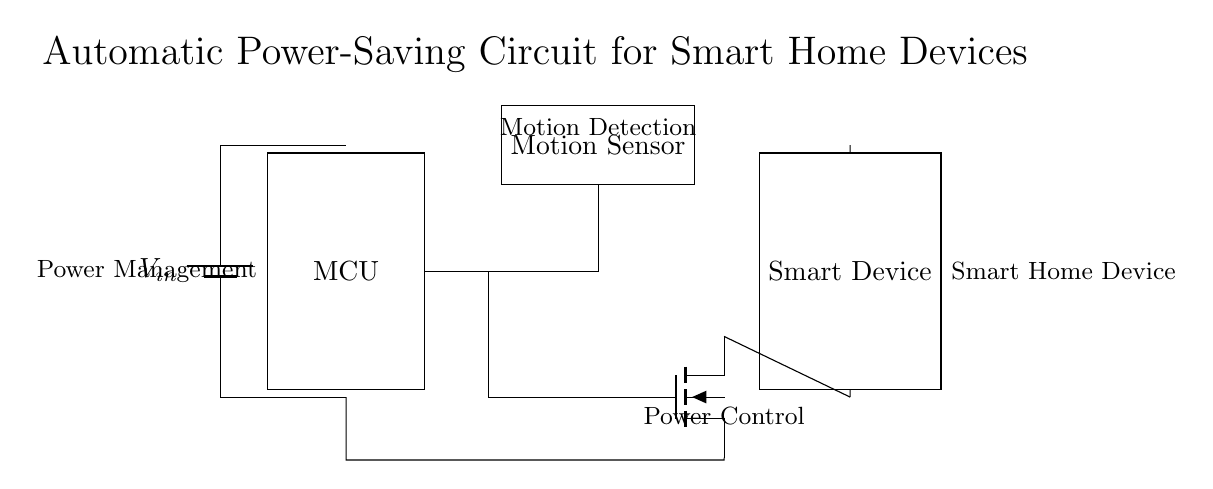What is the role of the microcontroller in this circuit? The microcontroller is responsible for managing the power, processing input from the motion sensor, and controlling the MOSFET to switch the smart device on and off.
Answer: Power management What component detects motion in this circuit? The motion sensor detects motion and sends a signal to the microcontroller to activate or deactivate the connected smart device.
Answer: Motion sensor How is the smart device powered in this circuit? The smart device is powered through the MOSFET, which acts as a switch controlled by the microcontroller based on the output from the motion sensor.
Answer: Through the MOSFET What type of transistor is used for power control? The circuit uses an N-channel MOSFET, which allows control over the power supplied to the smart device based on signals from the microcontroller.
Answer: N-channel MOSFET In what scenario would the smart device be turned off? The smart device would be turned off when no motion is detected by the motion sensor, which sends a signal to the microcontroller to deactivate the MOSFET.
Answer: No motion detected What happens when motion is detected? When motion is detected, the motion sensor sends a signal to the microcontroller, which activates the MOSFET to allow power to flow to the smart device, turning it on.
Answer: The smart device turns on 